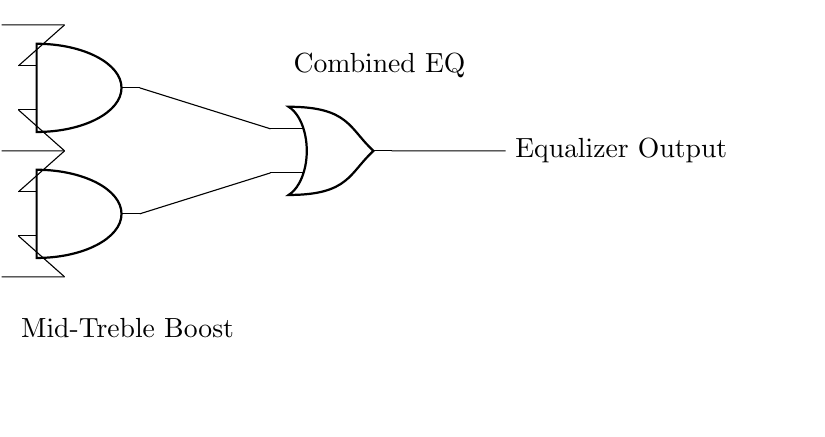What inputs are used in this circuit? The circuit utilizes three input signals labeled as Bass, Mid, and Treble. These inputs are essential for the equalizer control functionality.
Answer: Bass, Mid, Treble What type of logic gates are present in this circuit? The circuit contains AND gates and an OR gate, which are fundamental logic gates used for combining input signals for audio processing.
Answer: AND, OR How many AND gates are in the circuit? The diagram shows two AND gates, which are used to process the input signals from Bass, Mid, and Treble to create separate outputs before combining them.
Answer: 2 What does the output node represent? The output node labeled "Equalizer Output" represents the final mixed output of the audio signals processed by the logic gates in the equalizer circuit.
Answer: Equalizer Output What is the purpose of the first AND gate? The first AND gate combines the Bass and Mid signals to create a specific boost for those frequencies, enhancing their presence in the output mix.
Answer: Bass-Mid Boost What is the function of the OR gate? The OR gate combines the outputs from the two AND gates, allowing for a combined signal which includes all the boosts applied to the input frequencies.
Answer: Combined EQ Which frequency combination does the second AND gate boost? The second AND gate is designed to boost the Mid and Treble frequencies, ensuring a balanced mix for higher frequencies in the output.
Answer: Mid-Treble Boost 